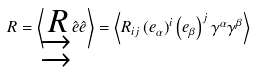Convert formula to latex. <formula><loc_0><loc_0><loc_500><loc_500>R = \left \langle \underrightarrow { \underrightarrow { R } } \hat { e } \hat { e } \right \rangle = \left \langle R _ { i j } \left ( e _ { \alpha } \right ) ^ { i } \left ( e _ { \beta } \right ) ^ { j } \gamma ^ { \alpha } \gamma ^ { \beta } \right \rangle</formula> 